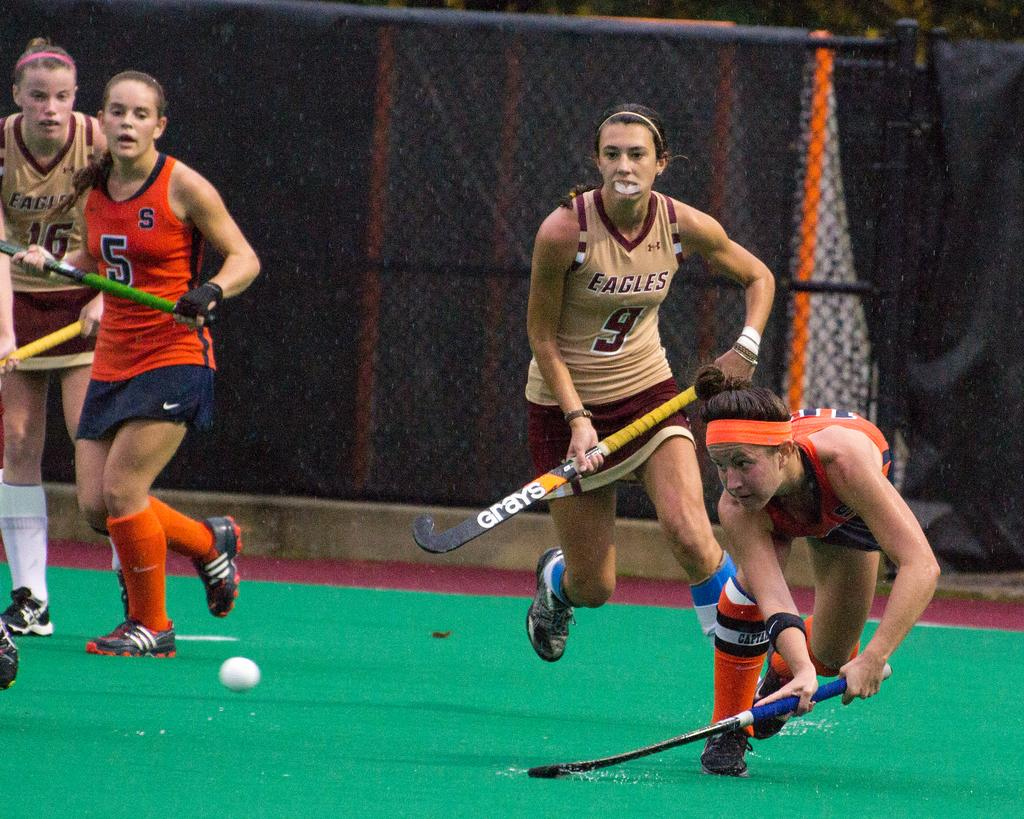<image>
Create a compact narrative representing the image presented. members of two teams playing some kind of game, including the eagles 9 and 16 and another team's 5. 